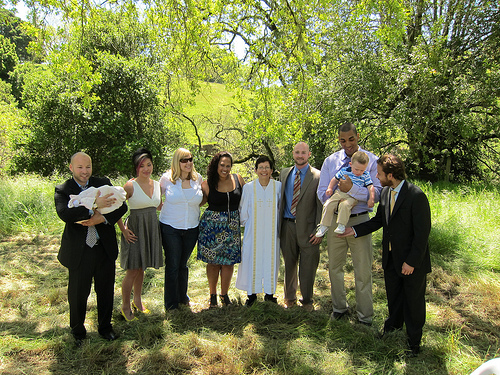<image>
Is the women to the left of the man? Yes. From this viewpoint, the women is positioned to the left side relative to the man. Is there a bearded man to the left of the tall man? No. The bearded man is not to the left of the tall man. From this viewpoint, they have a different horizontal relationship. 